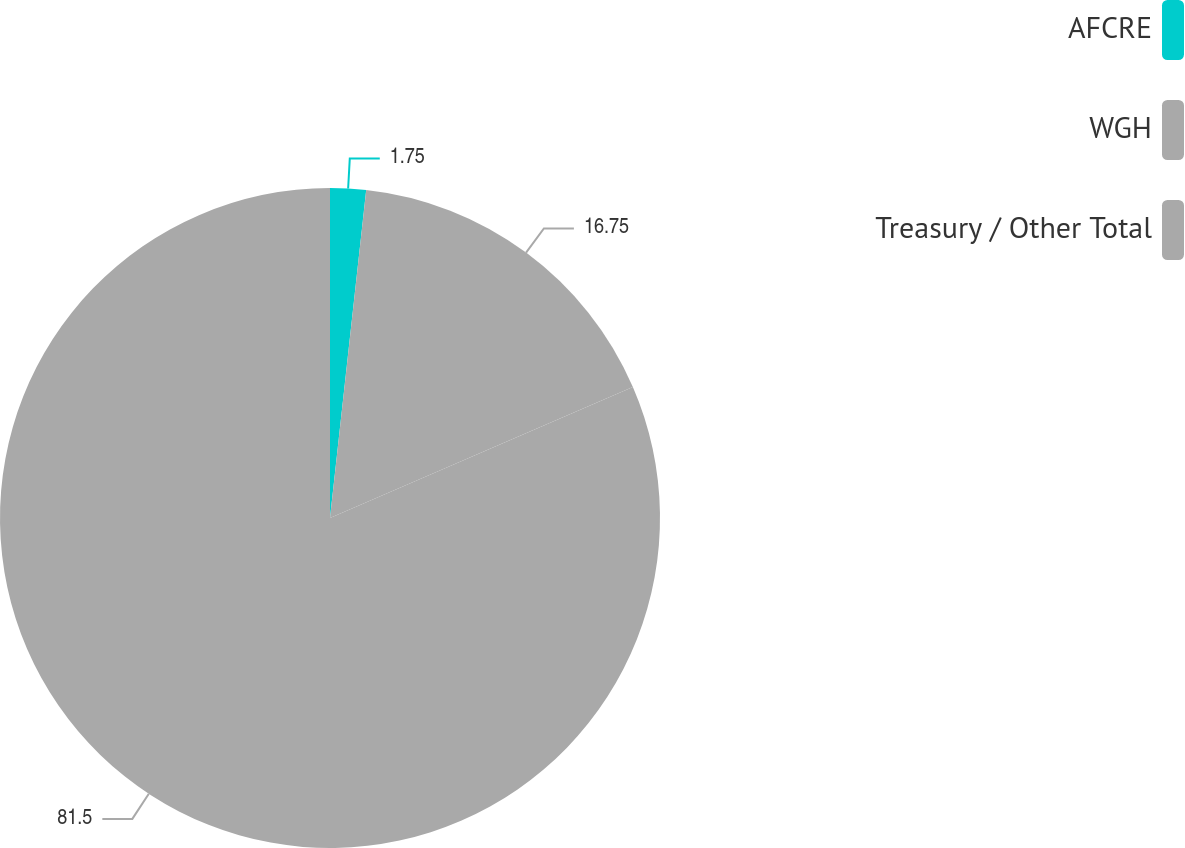Convert chart. <chart><loc_0><loc_0><loc_500><loc_500><pie_chart><fcel>AFCRE<fcel>WGH<fcel>Treasury / Other Total<nl><fcel>1.75%<fcel>16.75%<fcel>81.49%<nl></chart> 